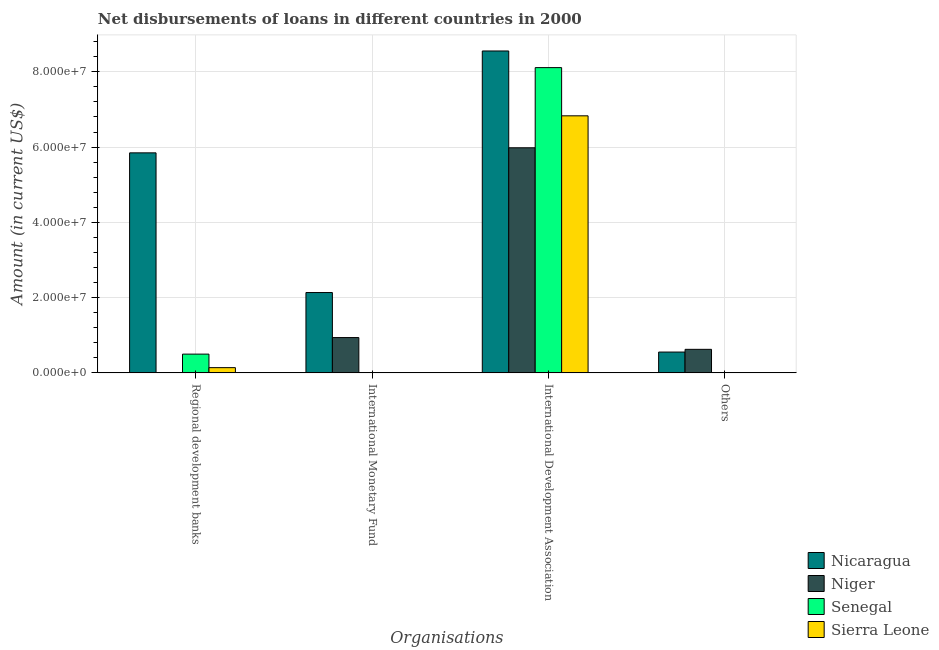How many groups of bars are there?
Offer a terse response. 4. Are the number of bars on each tick of the X-axis equal?
Your answer should be compact. No. How many bars are there on the 3rd tick from the right?
Offer a terse response. 2. What is the label of the 2nd group of bars from the left?
Offer a very short reply. International Monetary Fund. What is the amount of loan disimbursed by international monetary fund in Senegal?
Ensure brevity in your answer.  0. Across all countries, what is the maximum amount of loan disimbursed by regional development banks?
Give a very brief answer. 5.85e+07. Across all countries, what is the minimum amount of loan disimbursed by other organisations?
Keep it short and to the point. 0. In which country was the amount of loan disimbursed by international development association maximum?
Your answer should be very brief. Nicaragua. What is the total amount of loan disimbursed by other organisations in the graph?
Your answer should be very brief. 1.18e+07. What is the difference between the amount of loan disimbursed by international development association in Nicaragua and that in Sierra Leone?
Ensure brevity in your answer.  1.72e+07. What is the difference between the amount of loan disimbursed by other organisations in Senegal and the amount of loan disimbursed by international monetary fund in Sierra Leone?
Offer a very short reply. 0. What is the average amount of loan disimbursed by international development association per country?
Keep it short and to the point. 7.37e+07. What is the difference between the amount of loan disimbursed by international development association and amount of loan disimbursed by regional development banks in Sierra Leone?
Ensure brevity in your answer.  6.69e+07. What is the ratio of the amount of loan disimbursed by international development association in Nicaragua to that in Sierra Leone?
Give a very brief answer. 1.25. Is the amount of loan disimbursed by international development association in Niger less than that in Senegal?
Your answer should be compact. Yes. Is the difference between the amount of loan disimbursed by international development association in Sierra Leone and Senegal greater than the difference between the amount of loan disimbursed by regional development banks in Sierra Leone and Senegal?
Your answer should be very brief. No. What is the difference between the highest and the second highest amount of loan disimbursed by regional development banks?
Your answer should be very brief. 5.35e+07. What is the difference between the highest and the lowest amount of loan disimbursed by international monetary fund?
Provide a short and direct response. 2.13e+07. Is it the case that in every country, the sum of the amount of loan disimbursed by international development association and amount of loan disimbursed by international monetary fund is greater than the sum of amount of loan disimbursed by regional development banks and amount of loan disimbursed by other organisations?
Make the answer very short. Yes. Are all the bars in the graph horizontal?
Your response must be concise. No. What is the difference between two consecutive major ticks on the Y-axis?
Your answer should be very brief. 2.00e+07. Are the values on the major ticks of Y-axis written in scientific E-notation?
Your answer should be compact. Yes. Does the graph contain grids?
Make the answer very short. Yes. What is the title of the graph?
Keep it short and to the point. Net disbursements of loans in different countries in 2000. What is the label or title of the X-axis?
Provide a succinct answer. Organisations. What is the Amount (in current US$) in Nicaragua in Regional development banks?
Make the answer very short. 5.85e+07. What is the Amount (in current US$) in Senegal in Regional development banks?
Your answer should be compact. 4.98e+06. What is the Amount (in current US$) of Sierra Leone in Regional development banks?
Offer a terse response. 1.39e+06. What is the Amount (in current US$) in Nicaragua in International Monetary Fund?
Your answer should be very brief. 2.13e+07. What is the Amount (in current US$) of Niger in International Monetary Fund?
Give a very brief answer. 9.38e+06. What is the Amount (in current US$) in Nicaragua in International Development Association?
Give a very brief answer. 8.55e+07. What is the Amount (in current US$) of Niger in International Development Association?
Provide a short and direct response. 5.98e+07. What is the Amount (in current US$) of Senegal in International Development Association?
Ensure brevity in your answer.  8.11e+07. What is the Amount (in current US$) in Sierra Leone in International Development Association?
Ensure brevity in your answer.  6.83e+07. What is the Amount (in current US$) of Nicaragua in Others?
Ensure brevity in your answer.  5.53e+06. What is the Amount (in current US$) of Niger in Others?
Keep it short and to the point. 6.25e+06. Across all Organisations, what is the maximum Amount (in current US$) of Nicaragua?
Make the answer very short. 8.55e+07. Across all Organisations, what is the maximum Amount (in current US$) of Niger?
Your answer should be compact. 5.98e+07. Across all Organisations, what is the maximum Amount (in current US$) in Senegal?
Your answer should be compact. 8.11e+07. Across all Organisations, what is the maximum Amount (in current US$) in Sierra Leone?
Keep it short and to the point. 6.83e+07. Across all Organisations, what is the minimum Amount (in current US$) in Nicaragua?
Provide a short and direct response. 5.53e+06. Across all Organisations, what is the minimum Amount (in current US$) of Sierra Leone?
Keep it short and to the point. 0. What is the total Amount (in current US$) of Nicaragua in the graph?
Ensure brevity in your answer.  1.71e+08. What is the total Amount (in current US$) of Niger in the graph?
Your response must be concise. 7.54e+07. What is the total Amount (in current US$) of Senegal in the graph?
Keep it short and to the point. 8.61e+07. What is the total Amount (in current US$) in Sierra Leone in the graph?
Your answer should be very brief. 6.97e+07. What is the difference between the Amount (in current US$) of Nicaragua in Regional development banks and that in International Monetary Fund?
Provide a succinct answer. 3.71e+07. What is the difference between the Amount (in current US$) of Nicaragua in Regional development banks and that in International Development Association?
Give a very brief answer. -2.71e+07. What is the difference between the Amount (in current US$) of Senegal in Regional development banks and that in International Development Association?
Your answer should be very brief. -7.61e+07. What is the difference between the Amount (in current US$) of Sierra Leone in Regional development banks and that in International Development Association?
Offer a terse response. -6.69e+07. What is the difference between the Amount (in current US$) of Nicaragua in Regional development banks and that in Others?
Keep it short and to the point. 5.29e+07. What is the difference between the Amount (in current US$) in Nicaragua in International Monetary Fund and that in International Development Association?
Your answer should be compact. -6.42e+07. What is the difference between the Amount (in current US$) in Niger in International Monetary Fund and that in International Development Association?
Keep it short and to the point. -5.04e+07. What is the difference between the Amount (in current US$) in Nicaragua in International Monetary Fund and that in Others?
Your response must be concise. 1.58e+07. What is the difference between the Amount (in current US$) in Niger in International Monetary Fund and that in Others?
Provide a succinct answer. 3.13e+06. What is the difference between the Amount (in current US$) of Nicaragua in International Development Association and that in Others?
Ensure brevity in your answer.  8.00e+07. What is the difference between the Amount (in current US$) of Niger in International Development Association and that in Others?
Keep it short and to the point. 5.36e+07. What is the difference between the Amount (in current US$) in Nicaragua in Regional development banks and the Amount (in current US$) in Niger in International Monetary Fund?
Provide a short and direct response. 4.91e+07. What is the difference between the Amount (in current US$) of Nicaragua in Regional development banks and the Amount (in current US$) of Niger in International Development Association?
Provide a succinct answer. -1.35e+06. What is the difference between the Amount (in current US$) of Nicaragua in Regional development banks and the Amount (in current US$) of Senegal in International Development Association?
Make the answer very short. -2.26e+07. What is the difference between the Amount (in current US$) in Nicaragua in Regional development banks and the Amount (in current US$) in Sierra Leone in International Development Association?
Offer a very short reply. -9.84e+06. What is the difference between the Amount (in current US$) in Senegal in Regional development banks and the Amount (in current US$) in Sierra Leone in International Development Association?
Make the answer very short. -6.33e+07. What is the difference between the Amount (in current US$) of Nicaragua in Regional development banks and the Amount (in current US$) of Niger in Others?
Your response must be concise. 5.22e+07. What is the difference between the Amount (in current US$) of Nicaragua in International Monetary Fund and the Amount (in current US$) of Niger in International Development Association?
Make the answer very short. -3.85e+07. What is the difference between the Amount (in current US$) in Nicaragua in International Monetary Fund and the Amount (in current US$) in Senegal in International Development Association?
Your answer should be compact. -5.98e+07. What is the difference between the Amount (in current US$) of Nicaragua in International Monetary Fund and the Amount (in current US$) of Sierra Leone in International Development Association?
Offer a terse response. -4.70e+07. What is the difference between the Amount (in current US$) in Niger in International Monetary Fund and the Amount (in current US$) in Senegal in International Development Association?
Your answer should be compact. -7.17e+07. What is the difference between the Amount (in current US$) of Niger in International Monetary Fund and the Amount (in current US$) of Sierra Leone in International Development Association?
Make the answer very short. -5.89e+07. What is the difference between the Amount (in current US$) in Nicaragua in International Monetary Fund and the Amount (in current US$) in Niger in Others?
Ensure brevity in your answer.  1.51e+07. What is the difference between the Amount (in current US$) in Nicaragua in International Development Association and the Amount (in current US$) in Niger in Others?
Offer a very short reply. 7.93e+07. What is the average Amount (in current US$) in Nicaragua per Organisations?
Your answer should be very brief. 4.27e+07. What is the average Amount (in current US$) of Niger per Organisations?
Your answer should be very brief. 1.89e+07. What is the average Amount (in current US$) of Senegal per Organisations?
Offer a terse response. 2.15e+07. What is the average Amount (in current US$) in Sierra Leone per Organisations?
Provide a succinct answer. 1.74e+07. What is the difference between the Amount (in current US$) in Nicaragua and Amount (in current US$) in Senegal in Regional development banks?
Offer a terse response. 5.35e+07. What is the difference between the Amount (in current US$) in Nicaragua and Amount (in current US$) in Sierra Leone in Regional development banks?
Ensure brevity in your answer.  5.71e+07. What is the difference between the Amount (in current US$) in Senegal and Amount (in current US$) in Sierra Leone in Regional development banks?
Keep it short and to the point. 3.59e+06. What is the difference between the Amount (in current US$) in Nicaragua and Amount (in current US$) in Niger in International Monetary Fund?
Make the answer very short. 1.20e+07. What is the difference between the Amount (in current US$) of Nicaragua and Amount (in current US$) of Niger in International Development Association?
Your answer should be compact. 2.57e+07. What is the difference between the Amount (in current US$) of Nicaragua and Amount (in current US$) of Senegal in International Development Association?
Ensure brevity in your answer.  4.42e+06. What is the difference between the Amount (in current US$) in Nicaragua and Amount (in current US$) in Sierra Leone in International Development Association?
Make the answer very short. 1.72e+07. What is the difference between the Amount (in current US$) of Niger and Amount (in current US$) of Senegal in International Development Association?
Ensure brevity in your answer.  -2.13e+07. What is the difference between the Amount (in current US$) in Niger and Amount (in current US$) in Sierra Leone in International Development Association?
Provide a succinct answer. -8.49e+06. What is the difference between the Amount (in current US$) of Senegal and Amount (in current US$) of Sierra Leone in International Development Association?
Offer a terse response. 1.28e+07. What is the difference between the Amount (in current US$) in Nicaragua and Amount (in current US$) in Niger in Others?
Make the answer very short. -7.22e+05. What is the ratio of the Amount (in current US$) of Nicaragua in Regional development banks to that in International Monetary Fund?
Provide a succinct answer. 2.74. What is the ratio of the Amount (in current US$) of Nicaragua in Regional development banks to that in International Development Association?
Make the answer very short. 0.68. What is the ratio of the Amount (in current US$) of Senegal in Regional development banks to that in International Development Association?
Your answer should be compact. 0.06. What is the ratio of the Amount (in current US$) in Sierra Leone in Regional development banks to that in International Development Association?
Your response must be concise. 0.02. What is the ratio of the Amount (in current US$) in Nicaragua in Regional development banks to that in Others?
Provide a short and direct response. 10.57. What is the ratio of the Amount (in current US$) of Nicaragua in International Monetary Fund to that in International Development Association?
Offer a terse response. 0.25. What is the ratio of the Amount (in current US$) in Niger in International Monetary Fund to that in International Development Association?
Provide a succinct answer. 0.16. What is the ratio of the Amount (in current US$) in Nicaragua in International Monetary Fund to that in Others?
Provide a short and direct response. 3.86. What is the ratio of the Amount (in current US$) of Niger in International Monetary Fund to that in Others?
Offer a terse response. 1.5. What is the ratio of the Amount (in current US$) of Nicaragua in International Development Association to that in Others?
Provide a short and direct response. 15.47. What is the ratio of the Amount (in current US$) in Niger in International Development Association to that in Others?
Offer a very short reply. 9.57. What is the difference between the highest and the second highest Amount (in current US$) of Nicaragua?
Provide a succinct answer. 2.71e+07. What is the difference between the highest and the second highest Amount (in current US$) of Niger?
Make the answer very short. 5.04e+07. What is the difference between the highest and the lowest Amount (in current US$) of Nicaragua?
Ensure brevity in your answer.  8.00e+07. What is the difference between the highest and the lowest Amount (in current US$) of Niger?
Your answer should be very brief. 5.98e+07. What is the difference between the highest and the lowest Amount (in current US$) in Senegal?
Keep it short and to the point. 8.11e+07. What is the difference between the highest and the lowest Amount (in current US$) in Sierra Leone?
Provide a short and direct response. 6.83e+07. 